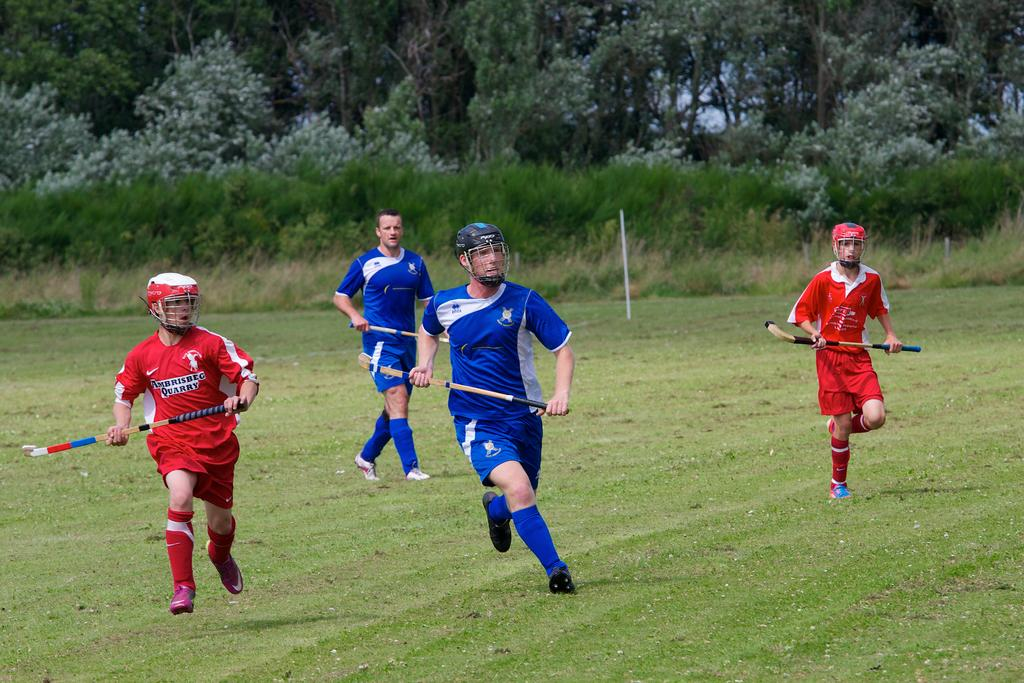<image>
Describe the image concisely. the word quarry is on the shirt of the person 